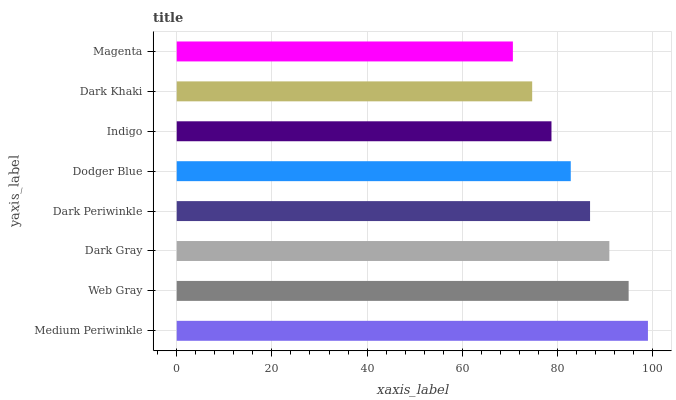Is Magenta the minimum?
Answer yes or no. Yes. Is Medium Periwinkle the maximum?
Answer yes or no. Yes. Is Web Gray the minimum?
Answer yes or no. No. Is Web Gray the maximum?
Answer yes or no. No. Is Medium Periwinkle greater than Web Gray?
Answer yes or no. Yes. Is Web Gray less than Medium Periwinkle?
Answer yes or no. Yes. Is Web Gray greater than Medium Periwinkle?
Answer yes or no. No. Is Medium Periwinkle less than Web Gray?
Answer yes or no. No. Is Dark Periwinkle the high median?
Answer yes or no. Yes. Is Dodger Blue the low median?
Answer yes or no. Yes. Is Indigo the high median?
Answer yes or no. No. Is Dark Khaki the low median?
Answer yes or no. No. 